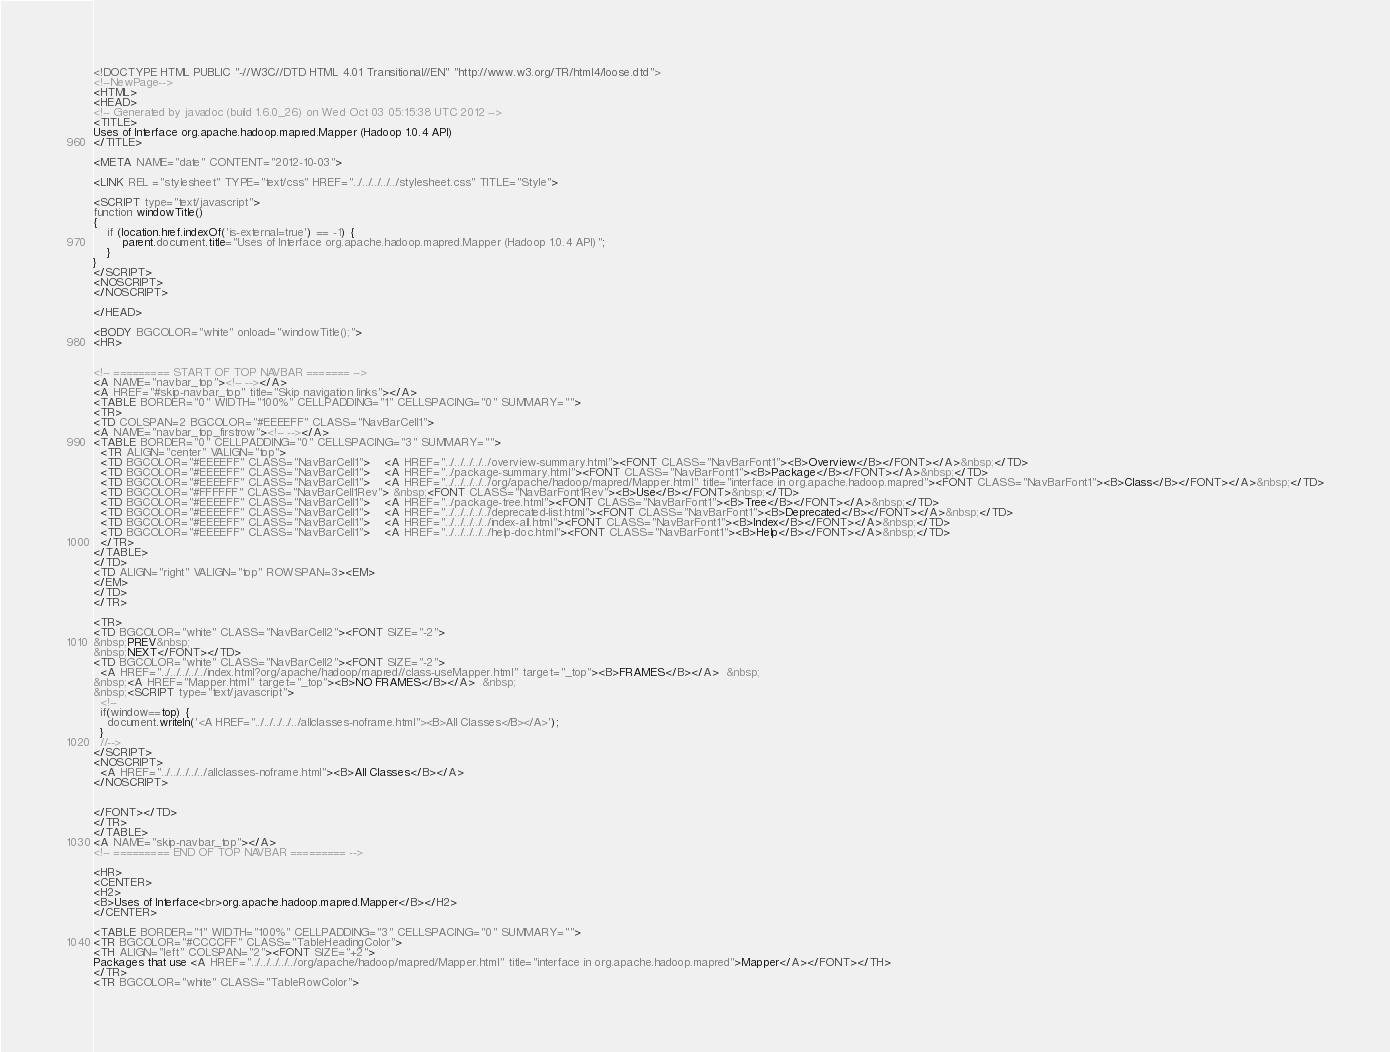Convert code to text. <code><loc_0><loc_0><loc_500><loc_500><_HTML_><!DOCTYPE HTML PUBLIC "-//W3C//DTD HTML 4.01 Transitional//EN" "http://www.w3.org/TR/html4/loose.dtd">
<!--NewPage-->
<HTML>
<HEAD>
<!-- Generated by javadoc (build 1.6.0_26) on Wed Oct 03 05:15:38 UTC 2012 -->
<TITLE>
Uses of Interface org.apache.hadoop.mapred.Mapper (Hadoop 1.0.4 API)
</TITLE>

<META NAME="date" CONTENT="2012-10-03">

<LINK REL ="stylesheet" TYPE="text/css" HREF="../../../../../stylesheet.css" TITLE="Style">

<SCRIPT type="text/javascript">
function windowTitle()
{
    if (location.href.indexOf('is-external=true') == -1) {
        parent.document.title="Uses of Interface org.apache.hadoop.mapred.Mapper (Hadoop 1.0.4 API)";
    }
}
</SCRIPT>
<NOSCRIPT>
</NOSCRIPT>

</HEAD>

<BODY BGCOLOR="white" onload="windowTitle();">
<HR>


<!-- ========= START OF TOP NAVBAR ======= -->
<A NAME="navbar_top"><!-- --></A>
<A HREF="#skip-navbar_top" title="Skip navigation links"></A>
<TABLE BORDER="0" WIDTH="100%" CELLPADDING="1" CELLSPACING="0" SUMMARY="">
<TR>
<TD COLSPAN=2 BGCOLOR="#EEEEFF" CLASS="NavBarCell1">
<A NAME="navbar_top_firstrow"><!-- --></A>
<TABLE BORDER="0" CELLPADDING="0" CELLSPACING="3" SUMMARY="">
  <TR ALIGN="center" VALIGN="top">
  <TD BGCOLOR="#EEEEFF" CLASS="NavBarCell1">    <A HREF="../../../../../overview-summary.html"><FONT CLASS="NavBarFont1"><B>Overview</B></FONT></A>&nbsp;</TD>
  <TD BGCOLOR="#EEEEFF" CLASS="NavBarCell1">    <A HREF="../package-summary.html"><FONT CLASS="NavBarFont1"><B>Package</B></FONT></A>&nbsp;</TD>
  <TD BGCOLOR="#EEEEFF" CLASS="NavBarCell1">    <A HREF="../../../../../org/apache/hadoop/mapred/Mapper.html" title="interface in org.apache.hadoop.mapred"><FONT CLASS="NavBarFont1"><B>Class</B></FONT></A>&nbsp;</TD>
  <TD BGCOLOR="#FFFFFF" CLASS="NavBarCell1Rev"> &nbsp;<FONT CLASS="NavBarFont1Rev"><B>Use</B></FONT>&nbsp;</TD>
  <TD BGCOLOR="#EEEEFF" CLASS="NavBarCell1">    <A HREF="../package-tree.html"><FONT CLASS="NavBarFont1"><B>Tree</B></FONT></A>&nbsp;</TD>
  <TD BGCOLOR="#EEEEFF" CLASS="NavBarCell1">    <A HREF="../../../../../deprecated-list.html"><FONT CLASS="NavBarFont1"><B>Deprecated</B></FONT></A>&nbsp;</TD>
  <TD BGCOLOR="#EEEEFF" CLASS="NavBarCell1">    <A HREF="../../../../../index-all.html"><FONT CLASS="NavBarFont1"><B>Index</B></FONT></A>&nbsp;</TD>
  <TD BGCOLOR="#EEEEFF" CLASS="NavBarCell1">    <A HREF="../../../../../help-doc.html"><FONT CLASS="NavBarFont1"><B>Help</B></FONT></A>&nbsp;</TD>
  </TR>
</TABLE>
</TD>
<TD ALIGN="right" VALIGN="top" ROWSPAN=3><EM>
</EM>
</TD>
</TR>

<TR>
<TD BGCOLOR="white" CLASS="NavBarCell2"><FONT SIZE="-2">
&nbsp;PREV&nbsp;
&nbsp;NEXT</FONT></TD>
<TD BGCOLOR="white" CLASS="NavBarCell2"><FONT SIZE="-2">
  <A HREF="../../../../../index.html?org/apache/hadoop/mapred//class-useMapper.html" target="_top"><B>FRAMES</B></A>  &nbsp;
&nbsp;<A HREF="Mapper.html" target="_top"><B>NO FRAMES</B></A>  &nbsp;
&nbsp;<SCRIPT type="text/javascript">
  <!--
  if(window==top) {
    document.writeln('<A HREF="../../../../../allclasses-noframe.html"><B>All Classes</B></A>');
  }
  //-->
</SCRIPT>
<NOSCRIPT>
  <A HREF="../../../../../allclasses-noframe.html"><B>All Classes</B></A>
</NOSCRIPT>


</FONT></TD>
</TR>
</TABLE>
<A NAME="skip-navbar_top"></A>
<!-- ========= END OF TOP NAVBAR ========= -->

<HR>
<CENTER>
<H2>
<B>Uses of Interface<br>org.apache.hadoop.mapred.Mapper</B></H2>
</CENTER>

<TABLE BORDER="1" WIDTH="100%" CELLPADDING="3" CELLSPACING="0" SUMMARY="">
<TR BGCOLOR="#CCCCFF" CLASS="TableHeadingColor">
<TH ALIGN="left" COLSPAN="2"><FONT SIZE="+2">
Packages that use <A HREF="../../../../../org/apache/hadoop/mapred/Mapper.html" title="interface in org.apache.hadoop.mapred">Mapper</A></FONT></TH>
</TR>
<TR BGCOLOR="white" CLASS="TableRowColor"></code> 